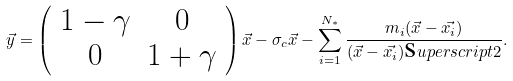Convert formula to latex. <formula><loc_0><loc_0><loc_500><loc_500>\vec { y } = \left ( \begin{array} { c c c } 1 - \gamma & 0 \\ 0 & 1 + \gamma \end{array} \right ) \vec { x } - { \sigma } _ { c } \vec { x } - \sum _ { i = 1 } ^ { N _ { * } } \frac { m _ { i } ( \vec { x } - \vec { x _ { i } } ) } { ( \vec { x } - \vec { x _ { i } } ) \text  superscript{2} } .</formula> 